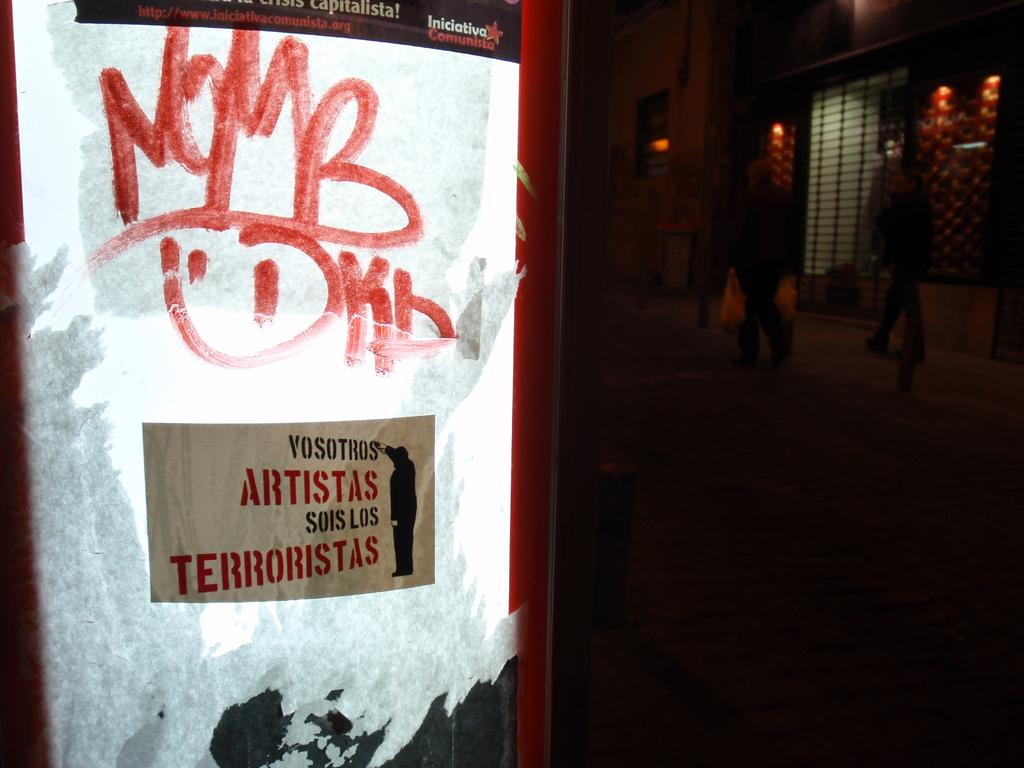Provide a one-sentence caption for the provided image. a a poster that has artistas written on it. 